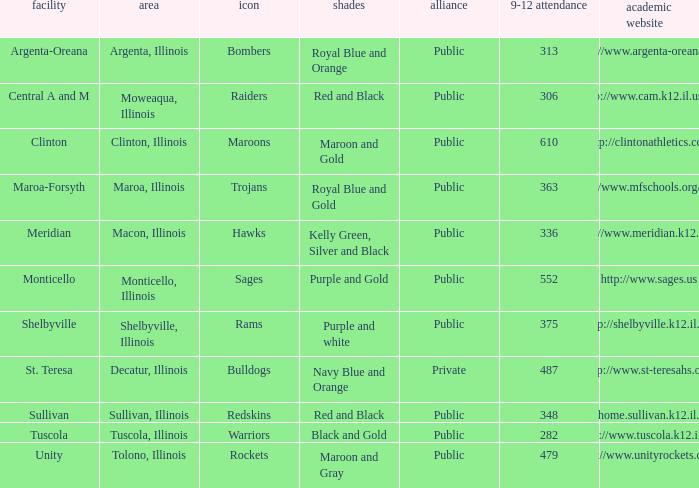What are the team colors from Tolono, Illinois? Maroon and Gray. 